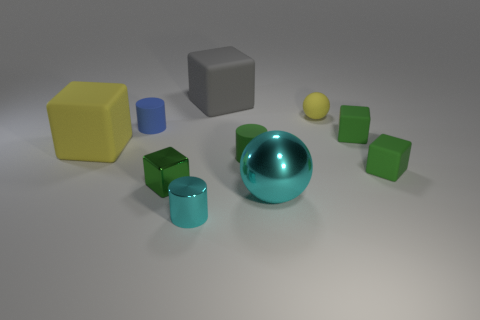Subtract all gray spheres. How many green cubes are left? 3 Subtract all large blocks. How many blocks are left? 3 Subtract all cylinders. How many objects are left? 7 Subtract all yellow spheres. How many spheres are left? 1 Subtract 2 blocks. How many blocks are left? 3 Subtract 0 blue balls. How many objects are left? 10 Subtract all red balls. Subtract all yellow cylinders. How many balls are left? 2 Subtract all cyan objects. Subtract all small blue cylinders. How many objects are left? 7 Add 9 cyan spheres. How many cyan spheres are left? 10 Add 3 tiny green rubber cylinders. How many tiny green rubber cylinders exist? 4 